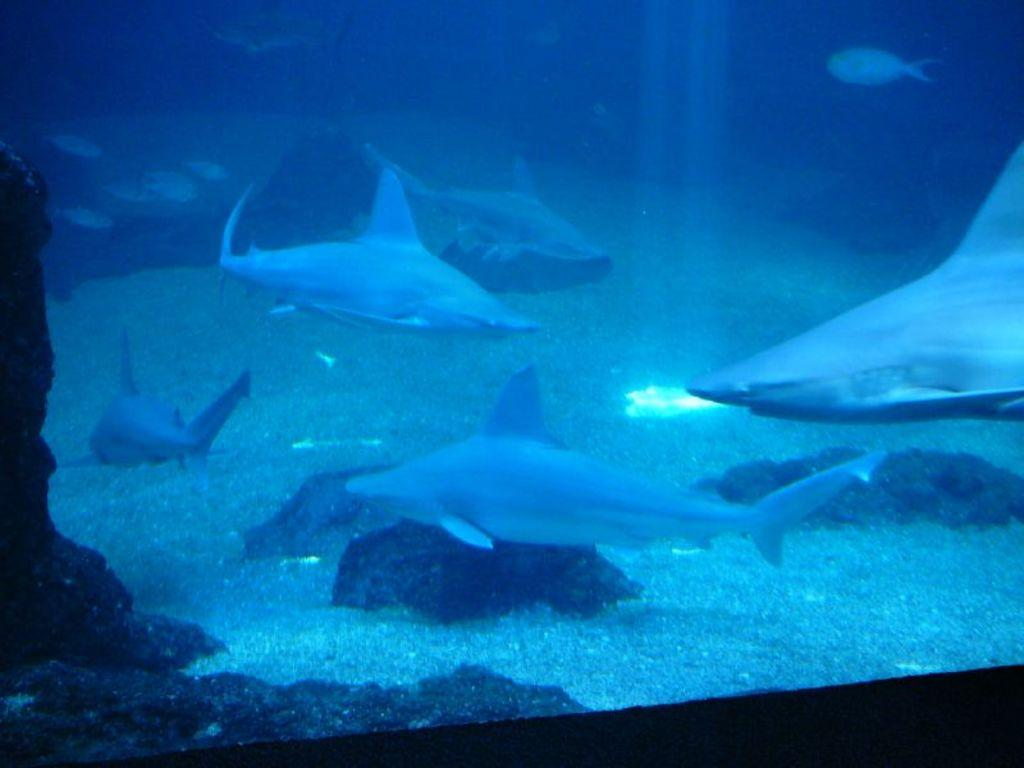What type of animals can be seen in the image? There are fish in the image. What other objects are present in the image? There are stones in the image. Where are the fish and stones located? The fish and stones are in the water. What shapes can be seen on the dolls in the image? There are no dolls present in the image; it features fish and stones in the water. 